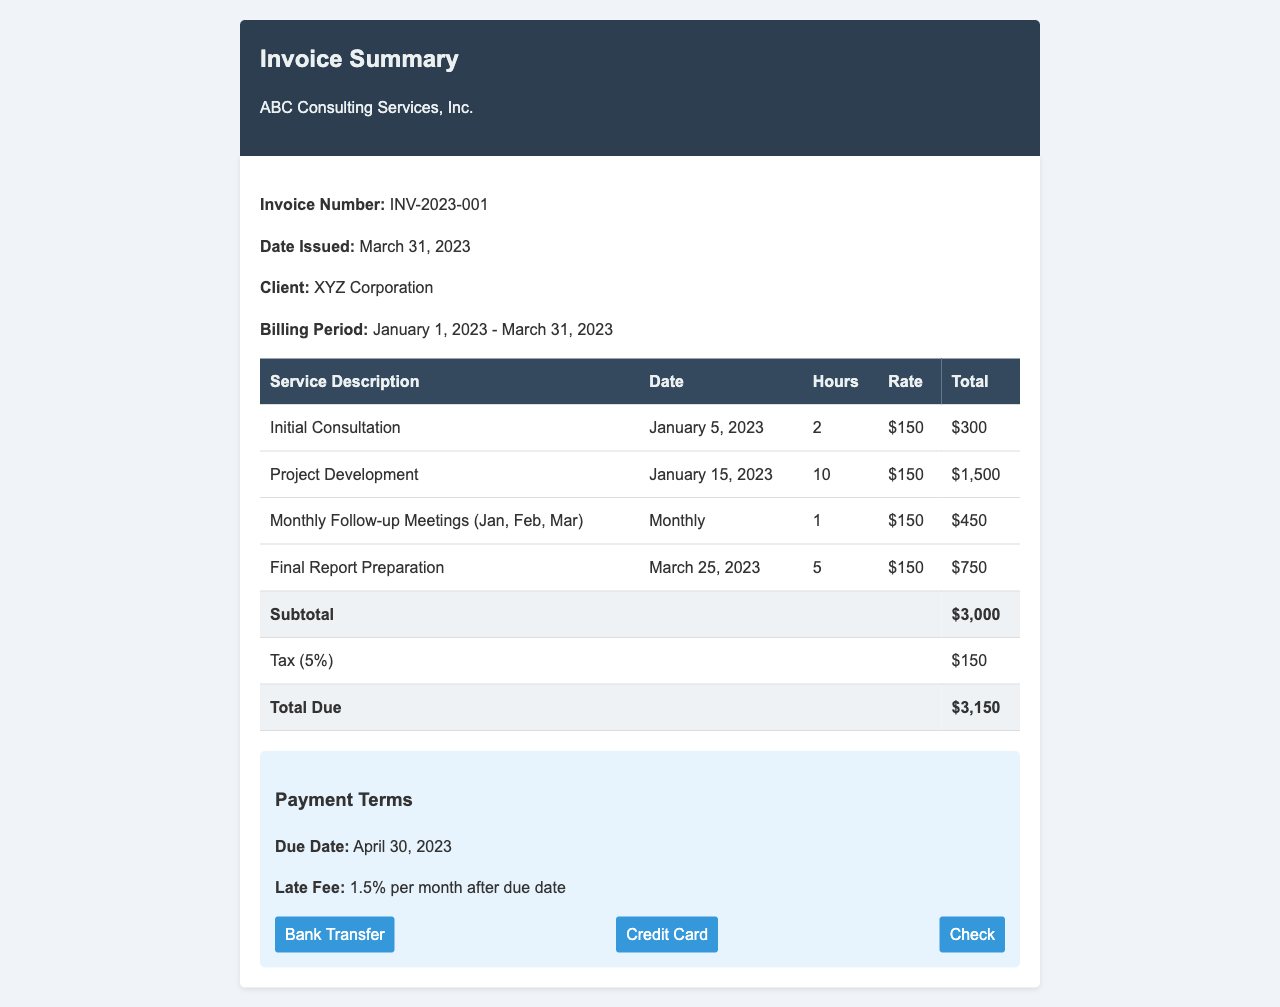What is the invoice number? The invoice number is listed to identify the document, which is INV-2023-001.
Answer: INV-2023-001 What is the total due amount? The total due amount is calculated at the end of the invoice, which is $3,150.
Answer: $3,150 Who is the client? The client is mentioned in the document, identified as XYZ Corporation.
Answer: XYZ Corporation What is the due date for payment? The due date for payment is explicitly stated in the payment terms section as April 30, 2023.
Answer: April 30, 2023 How much is the tax percentage applied? The tax percentage applied is shown next to the tax line, which is 5%.
Answer: 5% What service was rendered on January 5, 2023? The service rendered on January 5, 2023 is detailed in the table and described as Initial Consultation.
Answer: Initial Consultation What late fee applies after the due date? The late fee is specified as 1.5% per month after the due date.
Answer: 1.5% How many hours were billed for Final Report Preparation? The number of hours billed for Final Report Preparation is specified within the table, which is 5 hours.
Answer: 5 What payment methods are available? The available payment methods are listed at the bottom of the document, which are Bank Transfer, Credit Card, and Check.
Answer: Bank Transfer, Credit Card, Check 